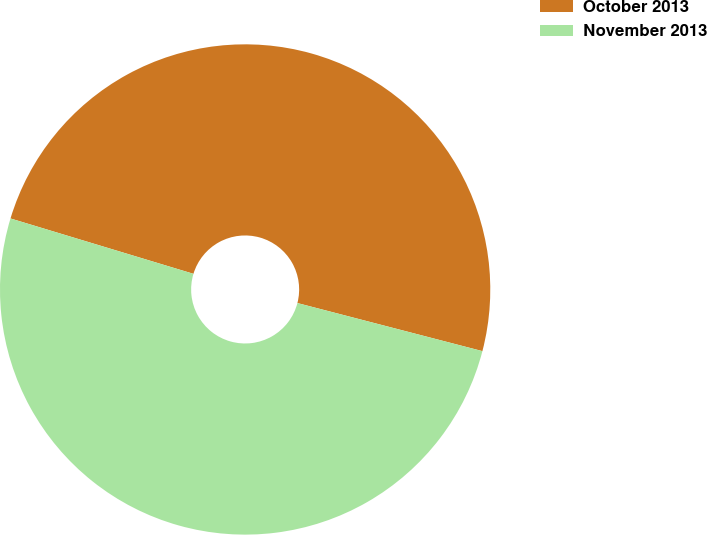<chart> <loc_0><loc_0><loc_500><loc_500><pie_chart><fcel>October 2013<fcel>November 2013<nl><fcel>49.37%<fcel>50.63%<nl></chart> 